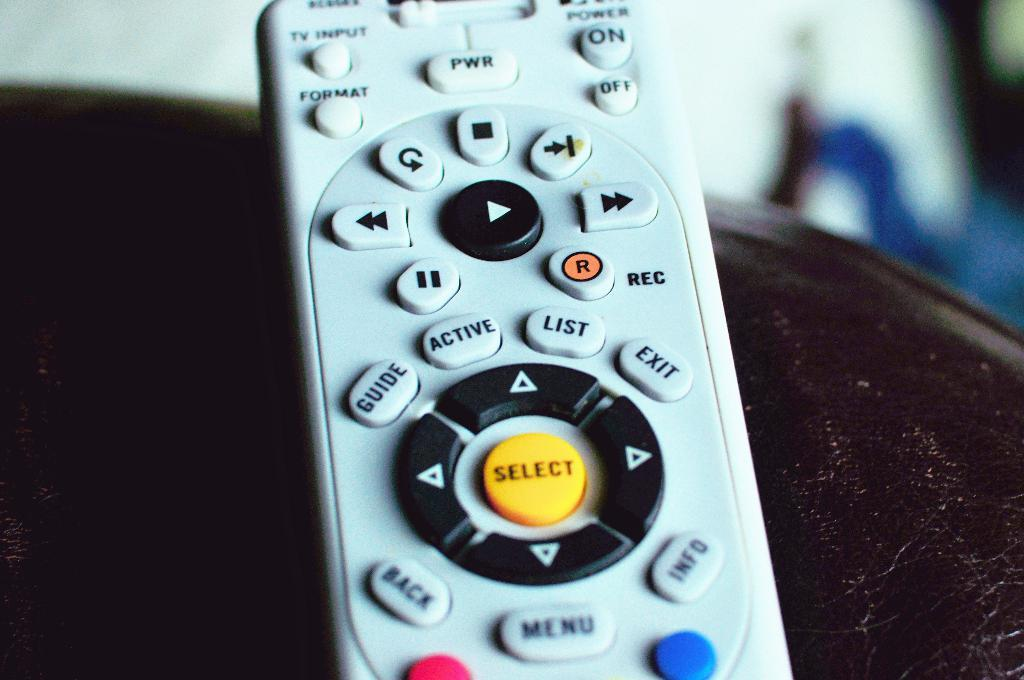<image>
Render a clear and concise summary of the photo. A closeup view of a television remote control with a bright yellow Select button in the center. 